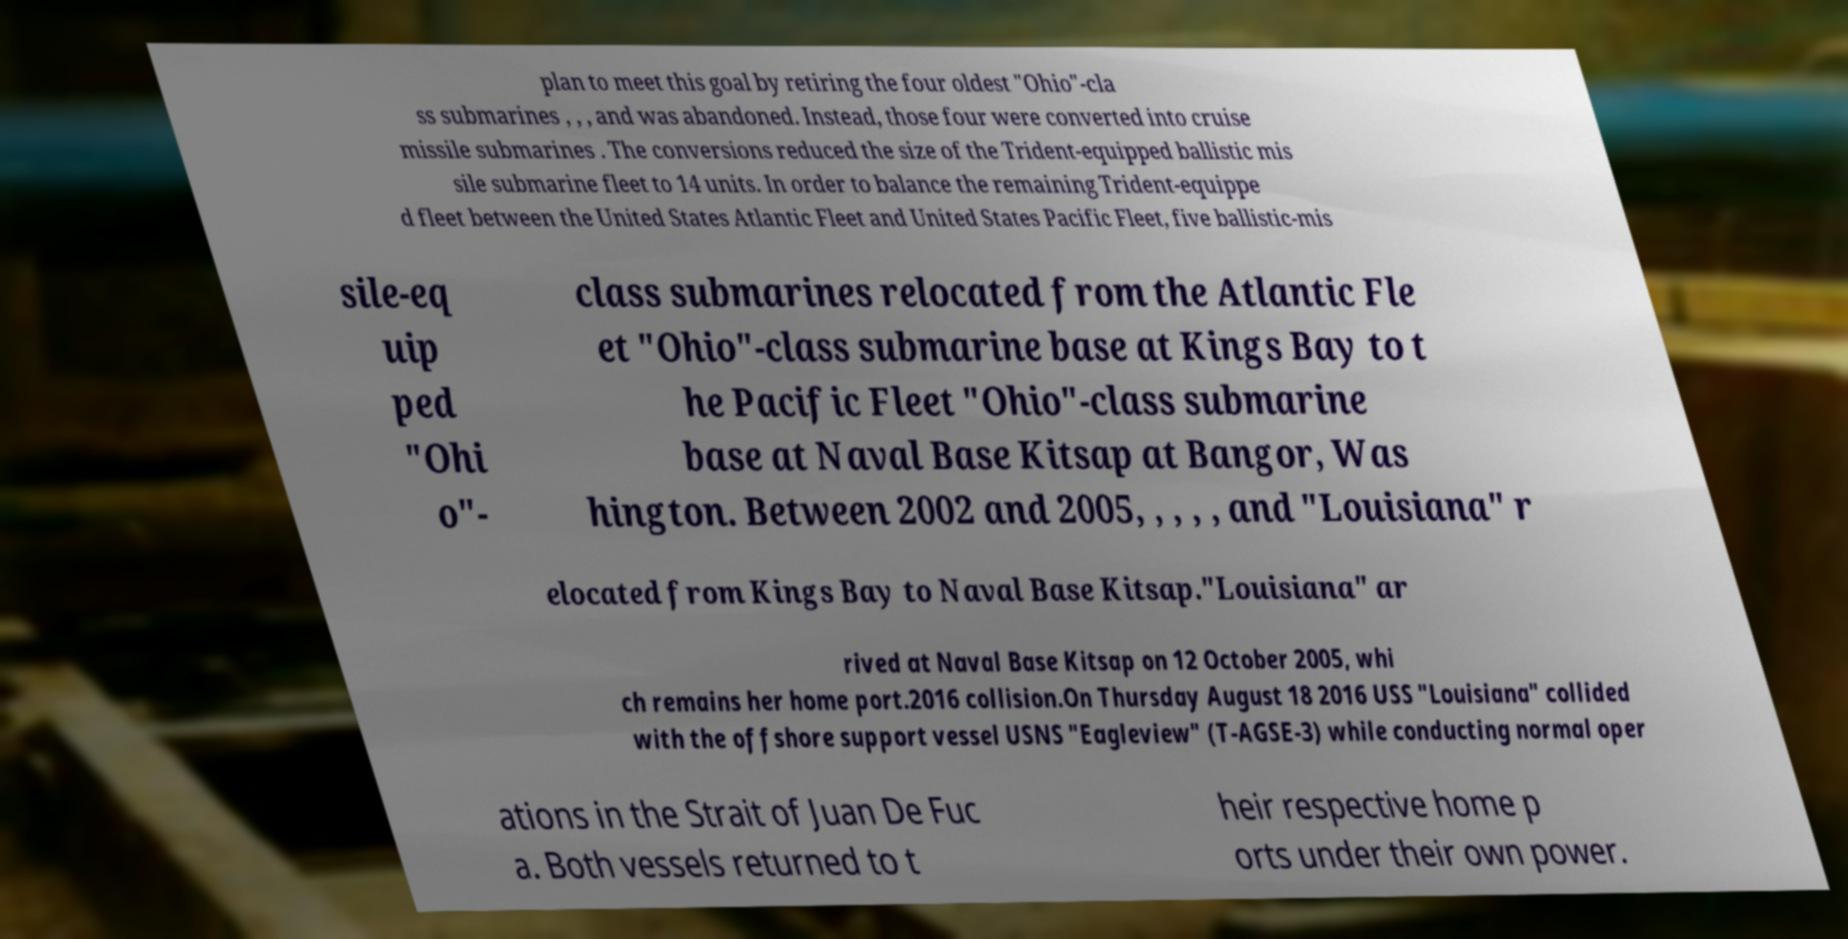There's text embedded in this image that I need extracted. Can you transcribe it verbatim? plan to meet this goal by retiring the four oldest "Ohio"-cla ss submarines , , , and was abandoned. Instead, those four were converted into cruise missile submarines . The conversions reduced the size of the Trident-equipped ballistic mis sile submarine fleet to 14 units. In order to balance the remaining Trident-equippe d fleet between the United States Atlantic Fleet and United States Pacific Fleet, five ballistic-mis sile-eq uip ped "Ohi o"- class submarines relocated from the Atlantic Fle et "Ohio"-class submarine base at Kings Bay to t he Pacific Fleet "Ohio"-class submarine base at Naval Base Kitsap at Bangor, Was hington. Between 2002 and 2005, , , , , and "Louisiana" r elocated from Kings Bay to Naval Base Kitsap."Louisiana" ar rived at Naval Base Kitsap on 12 October 2005, whi ch remains her home port.2016 collision.On Thursday August 18 2016 USS "Louisiana" collided with the offshore support vessel USNS "Eagleview" (T-AGSE-3) while conducting normal oper ations in the Strait of Juan De Fuc a. Both vessels returned to t heir respective home p orts under their own power. 